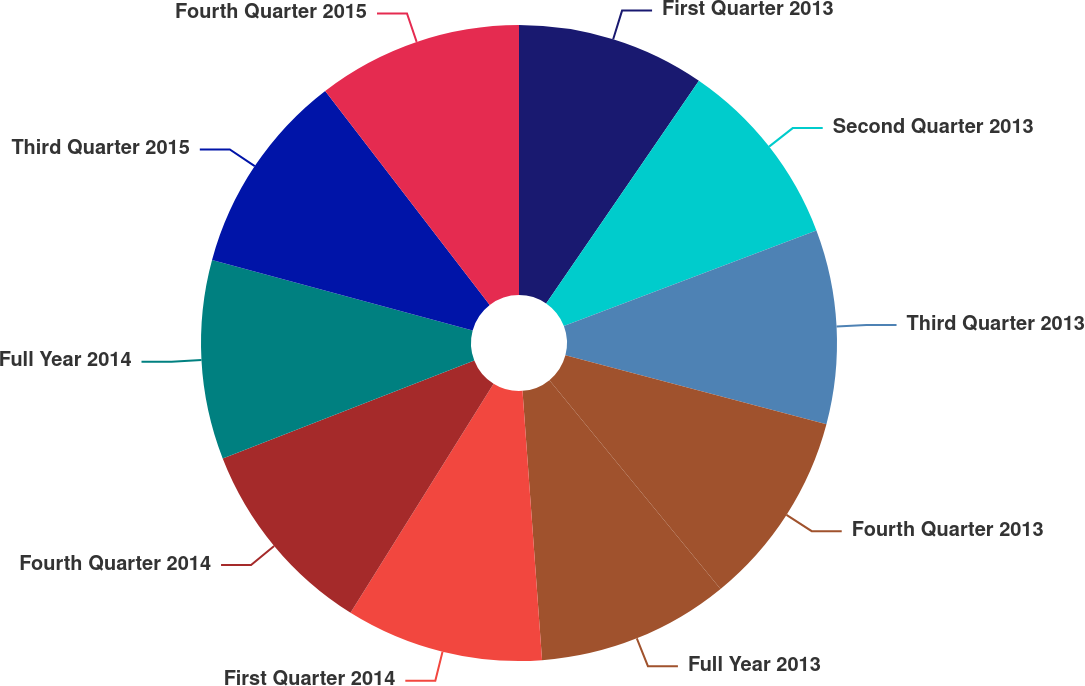<chart> <loc_0><loc_0><loc_500><loc_500><pie_chart><fcel>First Quarter 2013<fcel>Second Quarter 2013<fcel>Third Quarter 2013<fcel>Fourth Quarter 2013<fcel>Full Year 2013<fcel>First Quarter 2014<fcel>Fourth Quarter 2014<fcel>Full Year 2014<fcel>Third Quarter 2015<fcel>Fourth Quarter 2015<nl><fcel>9.57%<fcel>9.67%<fcel>9.87%<fcel>9.96%<fcel>9.77%<fcel>10.04%<fcel>10.2%<fcel>10.12%<fcel>10.36%<fcel>10.43%<nl></chart> 